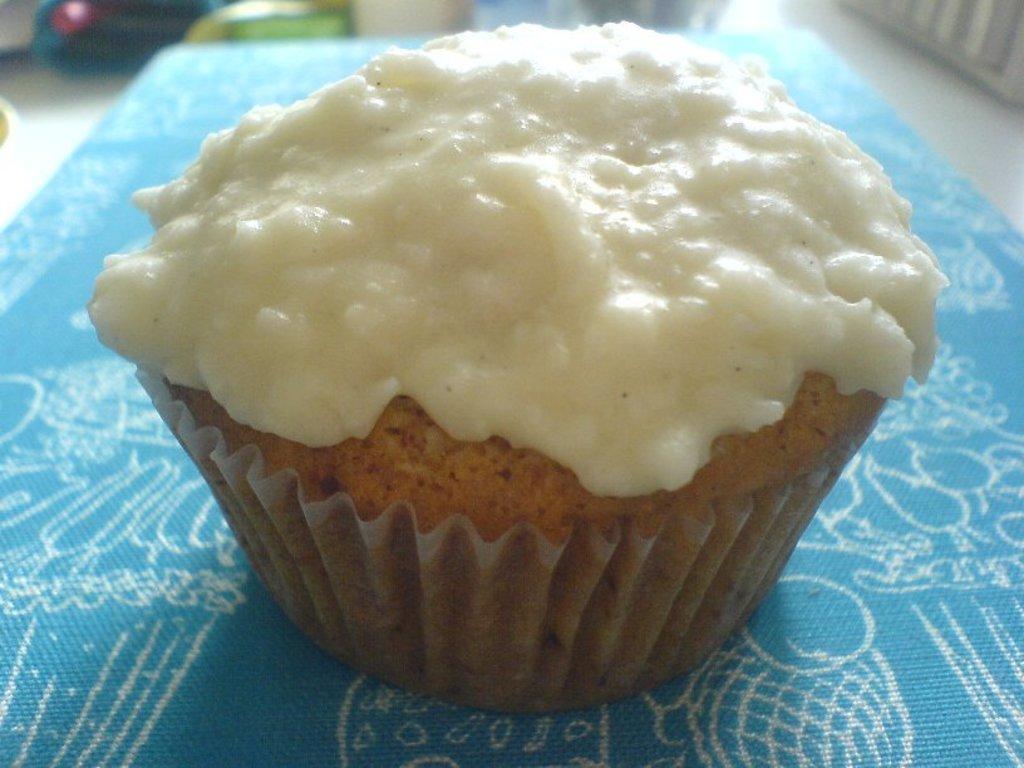Describe this image in one or two sentences. In this image I can see the blue and white colored surface and on it I can see a cupcake which is brown and cream in color. I can see the blurry background in which I can see few objects. 